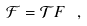<formula> <loc_0><loc_0><loc_500><loc_500>\mathcal { F } = \mathcal { T } F \ ,</formula> 